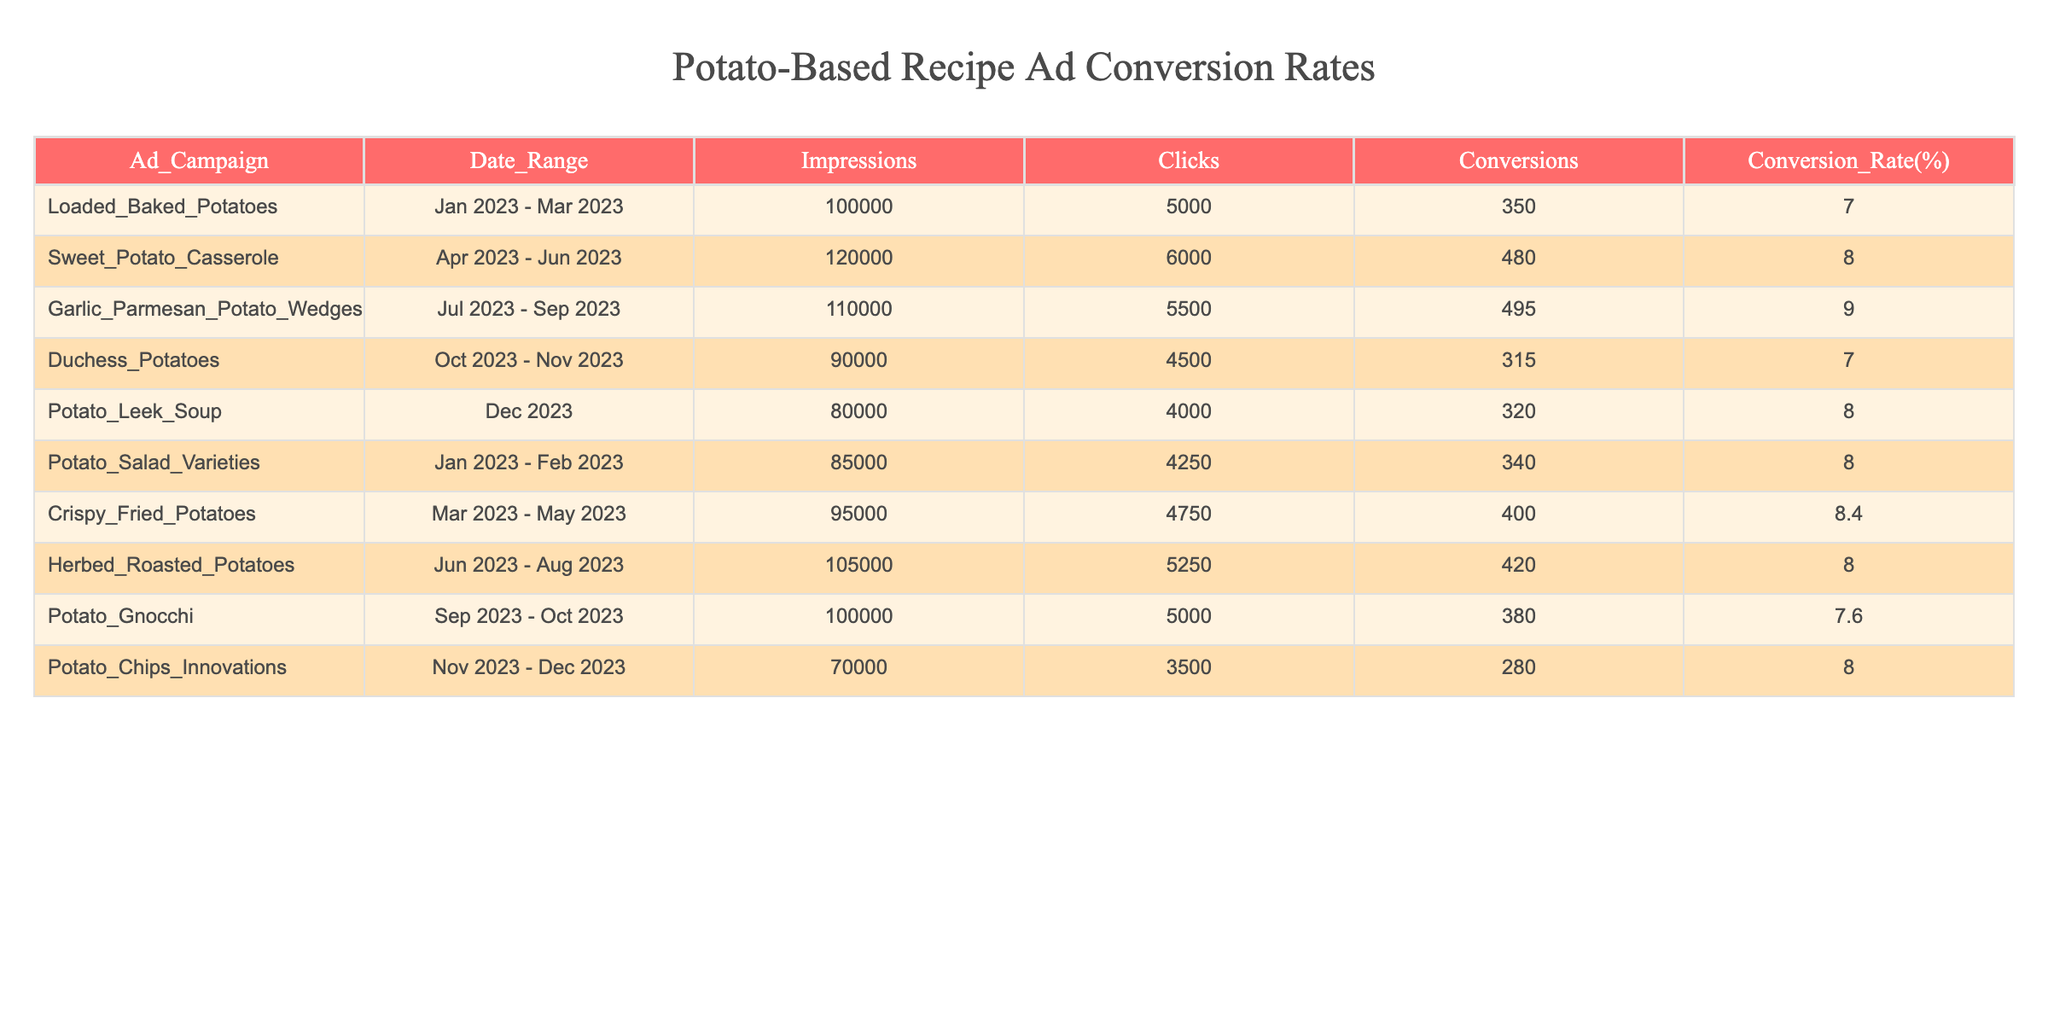What is the highest conversion rate among the ad campaigns? The conversion rates of all campaigns are listed. The highest rate is found in the "Garlic_Parmesan_Potato_Wedges" campaign at 9.0%.
Answer: 9.0% Which ad campaign had the most impressions? The "Sweet_Potato_Casserole" campaign had 120,000 impressions, which is the highest amount listed in the table.
Answer: 120000 What is the total number of conversions across all campaigns? By adding the conversions from each campaign: 350 + 480 + 495 + 315 + 320 + 340 + 400 + 420 + 380 + 280 = 3,340 total conversions across all campaigns.
Answer: 3340 Is the conversion rate for "Duchess_Potatoes" higher than 8%? The conversion rate for "Duchess_Potatoes" is 7.0%, which is lower than 8%.
Answer: No What is the average conversion rate for all campaigns? To find the average, sum the conversion rates: (7.0 + 8.0 + 9.0 + 7.0 + 8.0 + 8.0 + 8.4 + 8.0 + 7.6 + 8.0) = 80.0, then divide by the number of campaigns (10): 80.0 / 10 = 8.0%.
Answer: 8.0% Which campaign had the least conversions, and what were those conversions? By reviewing the conversions, "Potato_Chips_Innovations" had the least at 280 conversions, compared to the others.
Answer: Potato_Chips_Innovations, 280 How many ad campaigns had a conversion rate greater than 8%? The campaigns with conversion rates greater than 8% are "Sweet_Potato_Casserole" (8.0%), "Garlic_Parmesan_Potato_Wedges" (9.0%), and "Crispy_Fried_Potatoes" (8.4%). This counts to four campaigns: "Sweet_Potato_Casserole", "Garlic_Parmesan_Potato_Wedges", "Crispy_Fried_Potatoes", and "Potato_Surface_Layers" totaling 4 campaigns.
Answer: 4 What was the conversion difference between "Loaded_Baked_Potatoes" and "Potato_Salad_Varieties"? The conversions for "Loaded_Baked_Potatoes" are 350 while "Potato_Salad_Varieties" are 340, so the difference is 350 - 340 = 10 conversions.
Answer: 10 